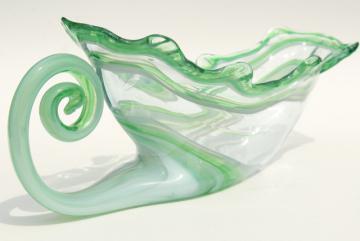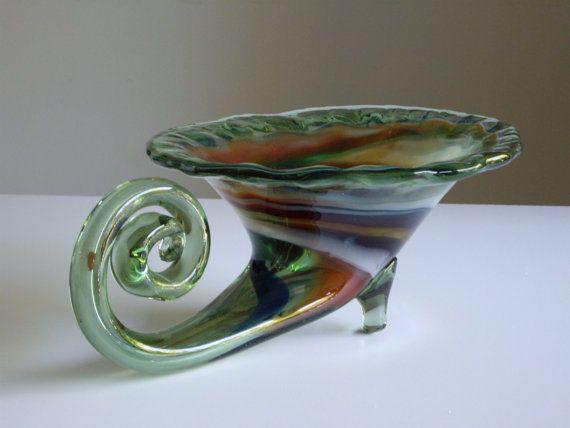The first image is the image on the left, the second image is the image on the right. Given the left and right images, does the statement "The right image contains two glass sculptures." hold true? Answer yes or no. No. The first image is the image on the left, the second image is the image on the right. Evaluate the accuracy of this statement regarding the images: "The left image shows one vase that tapers to a wave-curl at its bottom, and the right image shows at least one vase with a rounded bottom and no curl.". Is it true? Answer yes or no. No. 